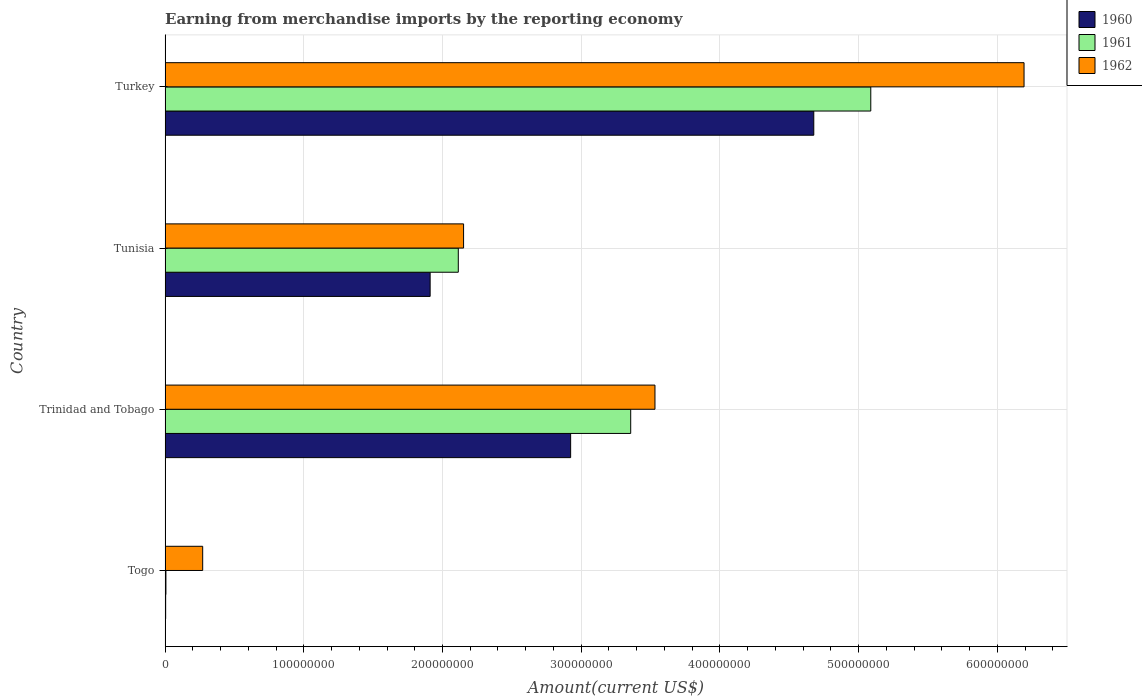Are the number of bars on each tick of the Y-axis equal?
Ensure brevity in your answer.  Yes. What is the label of the 3rd group of bars from the top?
Keep it short and to the point. Trinidad and Tobago. In how many cases, is the number of bars for a given country not equal to the number of legend labels?
Your answer should be very brief. 0. What is the amount earned from merchandise imports in 1961 in Trinidad and Tobago?
Your answer should be compact. 3.36e+08. Across all countries, what is the maximum amount earned from merchandise imports in 1961?
Your response must be concise. 5.09e+08. Across all countries, what is the minimum amount earned from merchandise imports in 1962?
Give a very brief answer. 2.71e+07. In which country was the amount earned from merchandise imports in 1961 minimum?
Your answer should be very brief. Togo. What is the total amount earned from merchandise imports in 1960 in the graph?
Your response must be concise. 9.52e+08. What is the difference between the amount earned from merchandise imports in 1960 in Tunisia and that in Turkey?
Offer a very short reply. -2.77e+08. What is the difference between the amount earned from merchandise imports in 1960 in Tunisia and the amount earned from merchandise imports in 1962 in Trinidad and Tobago?
Provide a succinct answer. -1.62e+08. What is the average amount earned from merchandise imports in 1962 per country?
Offer a terse response. 3.04e+08. What is the difference between the amount earned from merchandise imports in 1960 and amount earned from merchandise imports in 1962 in Trinidad and Tobago?
Your response must be concise. -6.08e+07. What is the ratio of the amount earned from merchandise imports in 1960 in Togo to that in Trinidad and Tobago?
Keep it short and to the point. 0. Is the difference between the amount earned from merchandise imports in 1960 in Togo and Trinidad and Tobago greater than the difference between the amount earned from merchandise imports in 1962 in Togo and Trinidad and Tobago?
Offer a very short reply. Yes. What is the difference between the highest and the second highest amount earned from merchandise imports in 1961?
Ensure brevity in your answer.  1.73e+08. What is the difference between the highest and the lowest amount earned from merchandise imports in 1960?
Your answer should be compact. 4.67e+08. Is the sum of the amount earned from merchandise imports in 1962 in Trinidad and Tobago and Turkey greater than the maximum amount earned from merchandise imports in 1961 across all countries?
Keep it short and to the point. Yes. What does the 1st bar from the bottom in Togo represents?
Your answer should be very brief. 1960. Is it the case that in every country, the sum of the amount earned from merchandise imports in 1962 and amount earned from merchandise imports in 1961 is greater than the amount earned from merchandise imports in 1960?
Provide a short and direct response. Yes. How many countries are there in the graph?
Your answer should be compact. 4. Does the graph contain grids?
Your answer should be very brief. Yes. How many legend labels are there?
Your answer should be compact. 3. What is the title of the graph?
Your response must be concise. Earning from merchandise imports by the reporting economy. What is the label or title of the X-axis?
Make the answer very short. Amount(current US$). What is the Amount(current US$) in 1962 in Togo?
Your answer should be compact. 2.71e+07. What is the Amount(current US$) of 1960 in Trinidad and Tobago?
Give a very brief answer. 2.92e+08. What is the Amount(current US$) in 1961 in Trinidad and Tobago?
Offer a terse response. 3.36e+08. What is the Amount(current US$) of 1962 in Trinidad and Tobago?
Offer a very short reply. 3.53e+08. What is the Amount(current US$) of 1960 in Tunisia?
Offer a terse response. 1.91e+08. What is the Amount(current US$) of 1961 in Tunisia?
Offer a very short reply. 2.11e+08. What is the Amount(current US$) in 1962 in Tunisia?
Offer a very short reply. 2.15e+08. What is the Amount(current US$) in 1960 in Turkey?
Your response must be concise. 4.68e+08. What is the Amount(current US$) of 1961 in Turkey?
Offer a terse response. 5.09e+08. What is the Amount(current US$) in 1962 in Turkey?
Make the answer very short. 6.19e+08. Across all countries, what is the maximum Amount(current US$) in 1960?
Your answer should be very brief. 4.68e+08. Across all countries, what is the maximum Amount(current US$) in 1961?
Your answer should be very brief. 5.09e+08. Across all countries, what is the maximum Amount(current US$) in 1962?
Give a very brief answer. 6.19e+08. Across all countries, what is the minimum Amount(current US$) in 1962?
Provide a succinct answer. 2.71e+07. What is the total Amount(current US$) of 1960 in the graph?
Offer a very short reply. 9.52e+08. What is the total Amount(current US$) in 1961 in the graph?
Give a very brief answer. 1.06e+09. What is the total Amount(current US$) of 1962 in the graph?
Give a very brief answer. 1.21e+09. What is the difference between the Amount(current US$) of 1960 in Togo and that in Trinidad and Tobago?
Your answer should be very brief. -2.92e+08. What is the difference between the Amount(current US$) of 1961 in Togo and that in Trinidad and Tobago?
Your answer should be compact. -3.35e+08. What is the difference between the Amount(current US$) in 1962 in Togo and that in Trinidad and Tobago?
Your answer should be very brief. -3.26e+08. What is the difference between the Amount(current US$) in 1960 in Togo and that in Tunisia?
Give a very brief answer. -1.91e+08. What is the difference between the Amount(current US$) of 1961 in Togo and that in Tunisia?
Offer a terse response. -2.11e+08. What is the difference between the Amount(current US$) of 1962 in Togo and that in Tunisia?
Offer a very short reply. -1.88e+08. What is the difference between the Amount(current US$) of 1960 in Togo and that in Turkey?
Your answer should be compact. -4.67e+08. What is the difference between the Amount(current US$) in 1961 in Togo and that in Turkey?
Provide a succinct answer. -5.08e+08. What is the difference between the Amount(current US$) of 1962 in Togo and that in Turkey?
Offer a terse response. -5.92e+08. What is the difference between the Amount(current US$) in 1960 in Trinidad and Tobago and that in Tunisia?
Give a very brief answer. 1.01e+08. What is the difference between the Amount(current US$) of 1961 in Trinidad and Tobago and that in Tunisia?
Offer a very short reply. 1.24e+08. What is the difference between the Amount(current US$) of 1962 in Trinidad and Tobago and that in Tunisia?
Your answer should be very brief. 1.38e+08. What is the difference between the Amount(current US$) of 1960 in Trinidad and Tobago and that in Turkey?
Give a very brief answer. -1.75e+08. What is the difference between the Amount(current US$) in 1961 in Trinidad and Tobago and that in Turkey?
Your answer should be compact. -1.73e+08. What is the difference between the Amount(current US$) in 1962 in Trinidad and Tobago and that in Turkey?
Keep it short and to the point. -2.66e+08. What is the difference between the Amount(current US$) in 1960 in Tunisia and that in Turkey?
Ensure brevity in your answer.  -2.77e+08. What is the difference between the Amount(current US$) in 1961 in Tunisia and that in Turkey?
Offer a very short reply. -2.97e+08. What is the difference between the Amount(current US$) in 1962 in Tunisia and that in Turkey?
Keep it short and to the point. -4.04e+08. What is the difference between the Amount(current US$) in 1960 in Togo and the Amount(current US$) in 1961 in Trinidad and Tobago?
Offer a very short reply. -3.35e+08. What is the difference between the Amount(current US$) in 1960 in Togo and the Amount(current US$) in 1962 in Trinidad and Tobago?
Make the answer very short. -3.53e+08. What is the difference between the Amount(current US$) in 1961 in Togo and the Amount(current US$) in 1962 in Trinidad and Tobago?
Offer a very short reply. -3.53e+08. What is the difference between the Amount(current US$) in 1960 in Togo and the Amount(current US$) in 1961 in Tunisia?
Ensure brevity in your answer.  -2.11e+08. What is the difference between the Amount(current US$) of 1960 in Togo and the Amount(current US$) of 1962 in Tunisia?
Your answer should be compact. -2.15e+08. What is the difference between the Amount(current US$) of 1961 in Togo and the Amount(current US$) of 1962 in Tunisia?
Offer a terse response. -2.15e+08. What is the difference between the Amount(current US$) of 1960 in Togo and the Amount(current US$) of 1961 in Turkey?
Give a very brief answer. -5.08e+08. What is the difference between the Amount(current US$) in 1960 in Togo and the Amount(current US$) in 1962 in Turkey?
Offer a terse response. -6.19e+08. What is the difference between the Amount(current US$) in 1961 in Togo and the Amount(current US$) in 1962 in Turkey?
Your answer should be very brief. -6.19e+08. What is the difference between the Amount(current US$) of 1960 in Trinidad and Tobago and the Amount(current US$) of 1961 in Tunisia?
Keep it short and to the point. 8.10e+07. What is the difference between the Amount(current US$) in 1960 in Trinidad and Tobago and the Amount(current US$) in 1962 in Tunisia?
Ensure brevity in your answer.  7.72e+07. What is the difference between the Amount(current US$) of 1961 in Trinidad and Tobago and the Amount(current US$) of 1962 in Tunisia?
Provide a short and direct response. 1.20e+08. What is the difference between the Amount(current US$) in 1960 in Trinidad and Tobago and the Amount(current US$) in 1961 in Turkey?
Your answer should be compact. -2.16e+08. What is the difference between the Amount(current US$) of 1960 in Trinidad and Tobago and the Amount(current US$) of 1962 in Turkey?
Keep it short and to the point. -3.27e+08. What is the difference between the Amount(current US$) of 1961 in Trinidad and Tobago and the Amount(current US$) of 1962 in Turkey?
Give a very brief answer. -2.84e+08. What is the difference between the Amount(current US$) of 1960 in Tunisia and the Amount(current US$) of 1961 in Turkey?
Give a very brief answer. -3.18e+08. What is the difference between the Amount(current US$) of 1960 in Tunisia and the Amount(current US$) of 1962 in Turkey?
Ensure brevity in your answer.  -4.28e+08. What is the difference between the Amount(current US$) in 1961 in Tunisia and the Amount(current US$) in 1962 in Turkey?
Your answer should be compact. -4.08e+08. What is the average Amount(current US$) in 1960 per country?
Ensure brevity in your answer.  2.38e+08. What is the average Amount(current US$) of 1961 per country?
Offer a very short reply. 2.64e+08. What is the average Amount(current US$) of 1962 per country?
Offer a terse response. 3.04e+08. What is the difference between the Amount(current US$) in 1960 and Amount(current US$) in 1962 in Togo?
Offer a very short reply. -2.67e+07. What is the difference between the Amount(current US$) in 1961 and Amount(current US$) in 1962 in Togo?
Give a very brief answer. -2.65e+07. What is the difference between the Amount(current US$) of 1960 and Amount(current US$) of 1961 in Trinidad and Tobago?
Ensure brevity in your answer.  -4.33e+07. What is the difference between the Amount(current US$) of 1960 and Amount(current US$) of 1962 in Trinidad and Tobago?
Provide a succinct answer. -6.08e+07. What is the difference between the Amount(current US$) of 1961 and Amount(current US$) of 1962 in Trinidad and Tobago?
Provide a succinct answer. -1.75e+07. What is the difference between the Amount(current US$) of 1960 and Amount(current US$) of 1961 in Tunisia?
Your response must be concise. -2.03e+07. What is the difference between the Amount(current US$) of 1960 and Amount(current US$) of 1962 in Tunisia?
Your answer should be very brief. -2.41e+07. What is the difference between the Amount(current US$) of 1961 and Amount(current US$) of 1962 in Tunisia?
Provide a succinct answer. -3.80e+06. What is the difference between the Amount(current US$) in 1960 and Amount(current US$) in 1961 in Turkey?
Your response must be concise. -4.11e+07. What is the difference between the Amount(current US$) in 1960 and Amount(current US$) in 1962 in Turkey?
Ensure brevity in your answer.  -1.52e+08. What is the difference between the Amount(current US$) in 1961 and Amount(current US$) in 1962 in Turkey?
Offer a very short reply. -1.10e+08. What is the ratio of the Amount(current US$) of 1960 in Togo to that in Trinidad and Tobago?
Your response must be concise. 0. What is the ratio of the Amount(current US$) of 1961 in Togo to that in Trinidad and Tobago?
Ensure brevity in your answer.  0. What is the ratio of the Amount(current US$) of 1962 in Togo to that in Trinidad and Tobago?
Offer a terse response. 0.08. What is the ratio of the Amount(current US$) of 1960 in Togo to that in Tunisia?
Make the answer very short. 0. What is the ratio of the Amount(current US$) of 1961 in Togo to that in Tunisia?
Keep it short and to the point. 0. What is the ratio of the Amount(current US$) in 1962 in Togo to that in Tunisia?
Give a very brief answer. 0.13. What is the ratio of the Amount(current US$) in 1960 in Togo to that in Turkey?
Make the answer very short. 0. What is the ratio of the Amount(current US$) of 1961 in Togo to that in Turkey?
Provide a succinct answer. 0. What is the ratio of the Amount(current US$) in 1962 in Togo to that in Turkey?
Ensure brevity in your answer.  0.04. What is the ratio of the Amount(current US$) of 1960 in Trinidad and Tobago to that in Tunisia?
Offer a terse response. 1.53. What is the ratio of the Amount(current US$) of 1961 in Trinidad and Tobago to that in Tunisia?
Provide a short and direct response. 1.59. What is the ratio of the Amount(current US$) of 1962 in Trinidad and Tobago to that in Tunisia?
Provide a succinct answer. 1.64. What is the ratio of the Amount(current US$) in 1960 in Trinidad and Tobago to that in Turkey?
Keep it short and to the point. 0.63. What is the ratio of the Amount(current US$) of 1961 in Trinidad and Tobago to that in Turkey?
Offer a very short reply. 0.66. What is the ratio of the Amount(current US$) in 1962 in Trinidad and Tobago to that in Turkey?
Give a very brief answer. 0.57. What is the ratio of the Amount(current US$) of 1960 in Tunisia to that in Turkey?
Your answer should be compact. 0.41. What is the ratio of the Amount(current US$) in 1961 in Tunisia to that in Turkey?
Provide a short and direct response. 0.42. What is the ratio of the Amount(current US$) of 1962 in Tunisia to that in Turkey?
Provide a succinct answer. 0.35. What is the difference between the highest and the second highest Amount(current US$) of 1960?
Provide a succinct answer. 1.75e+08. What is the difference between the highest and the second highest Amount(current US$) of 1961?
Your answer should be compact. 1.73e+08. What is the difference between the highest and the second highest Amount(current US$) in 1962?
Your response must be concise. 2.66e+08. What is the difference between the highest and the lowest Amount(current US$) of 1960?
Ensure brevity in your answer.  4.67e+08. What is the difference between the highest and the lowest Amount(current US$) in 1961?
Provide a short and direct response. 5.08e+08. What is the difference between the highest and the lowest Amount(current US$) of 1962?
Give a very brief answer. 5.92e+08. 